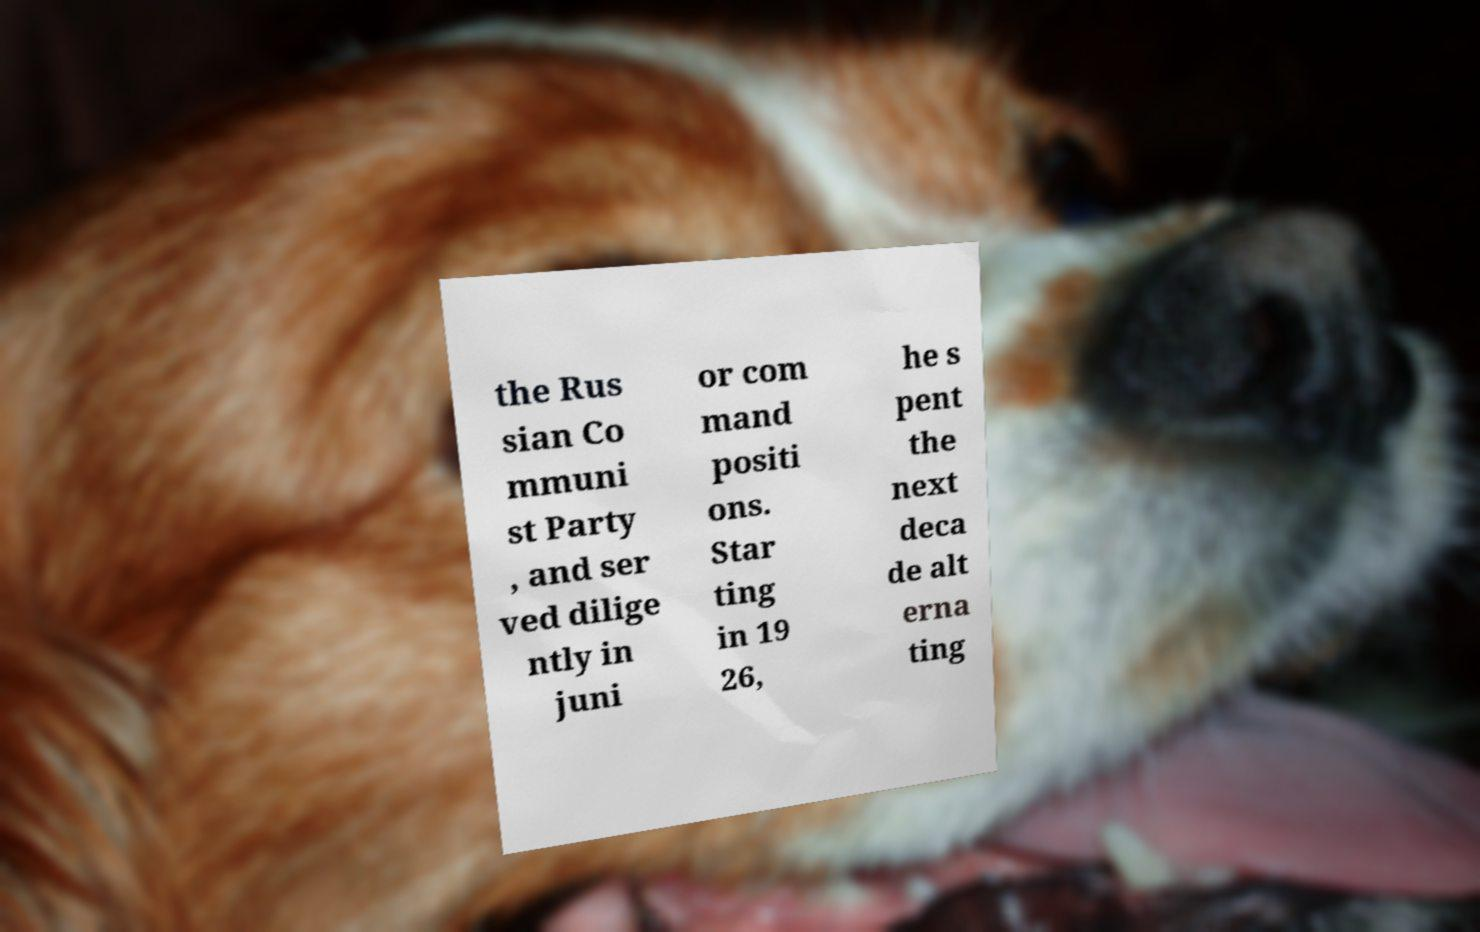Please read and relay the text visible in this image. What does it say? the Rus sian Co mmuni st Party , and ser ved dilige ntly in juni or com mand positi ons. Star ting in 19 26, he s pent the next deca de alt erna ting 